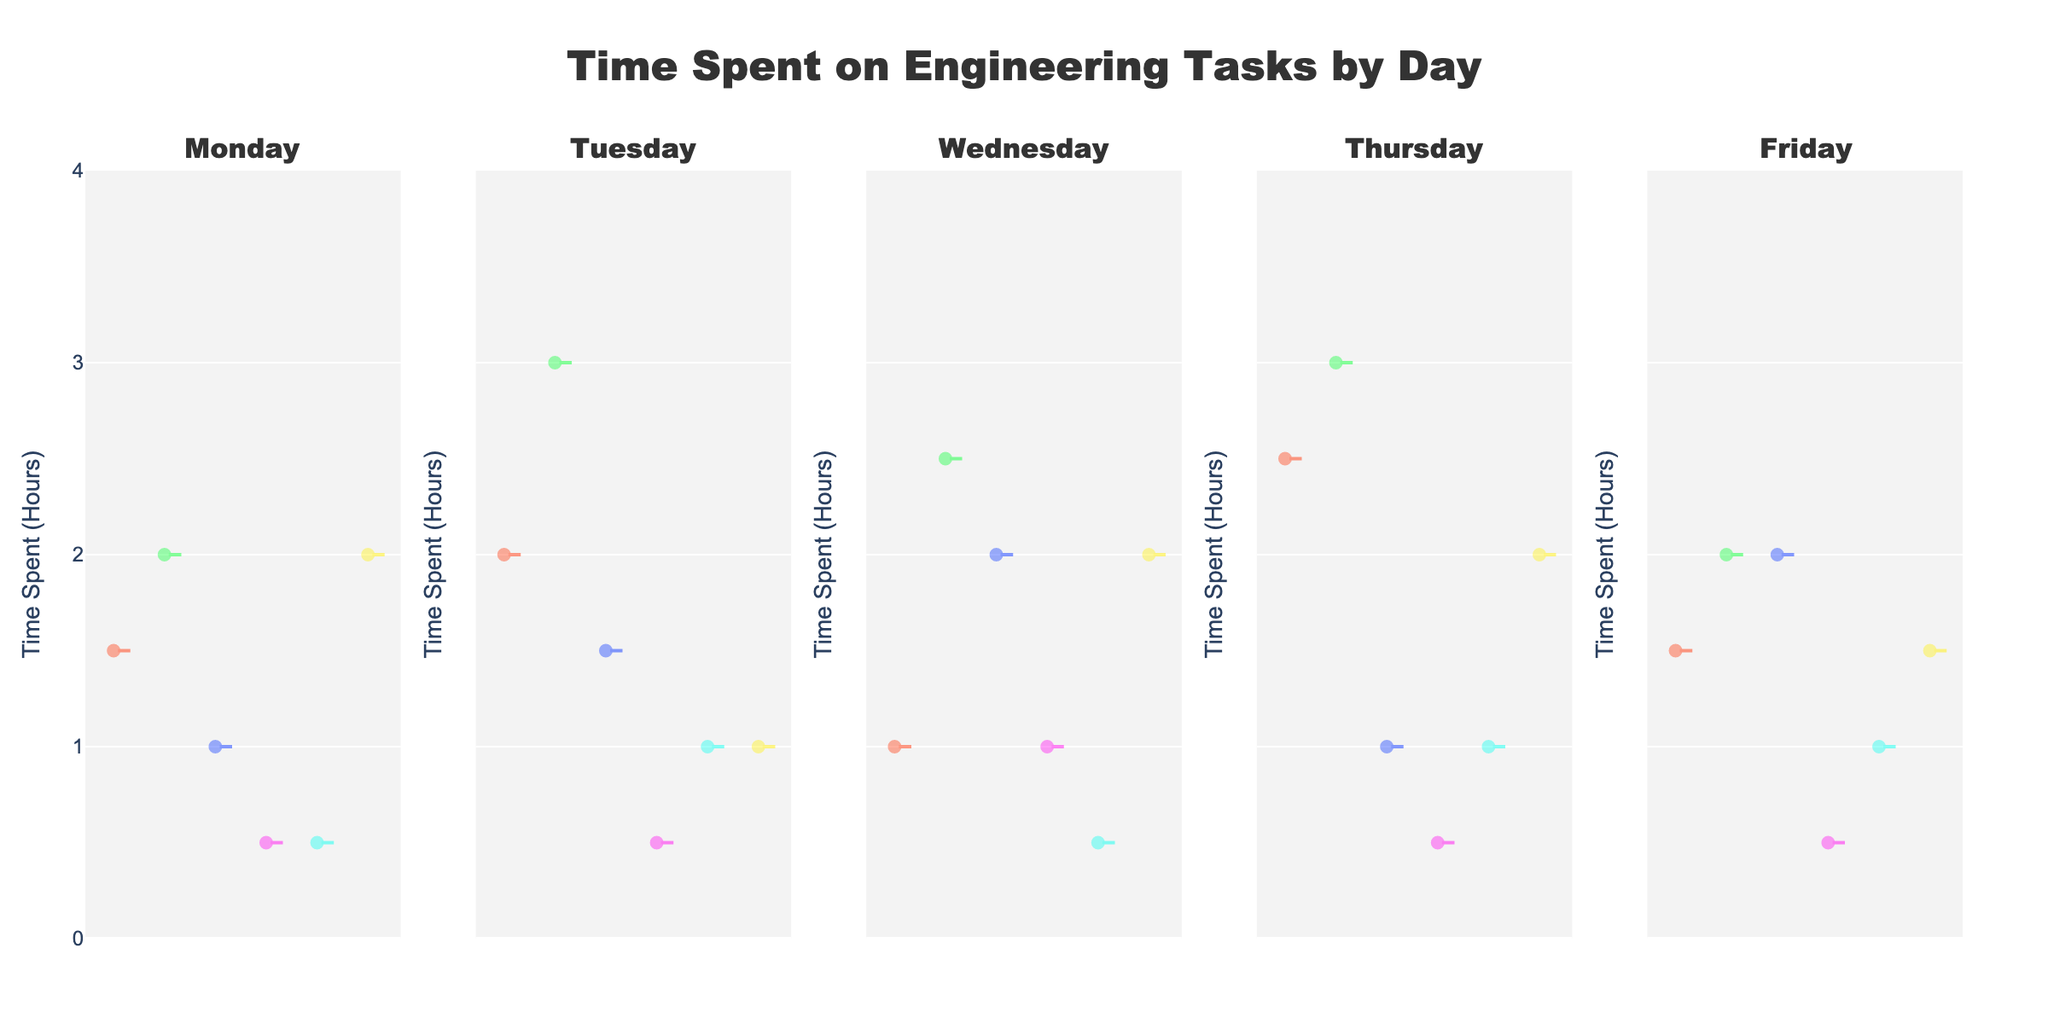What's the title of the figure? The title is usually found at the top of the figure and it provides a brief description of what the figure is about. In this case, the title is "Time Spent on Engineering Tasks by Day".
Answer: Time Spent on Engineering Tasks by Day What's the y-axis label on the figure? The y-axis label is typically along the vertical axis and specifies what is being measured. In this figure, the y-axis label is "Time Spent (Hours)".
Answer: Time Spent (Hours) Which two tasks have the highest median time spent on Tuesday? To determine the median time spent on Tuesday, locate the violin plots under the Tuesday subplot and observe which tasks have the highest medians (the widest parts at the center). Circuit Design and Coding have the highest medians on Tuesday.
Answer: Circuit Design, Coding Which day has the widest spread in time spent on Coding? Observe the violin plots for Coding on each day and note which day has the largest spread (the widest plot vertically). Thursday has the largest spread for Coding.
Answer: Thursday What is the smallest amount of time spent on Client Meeting on any day? Look at the violin plots for Client Meeting across all days. The smallest amount of time is seen on Tuesday and Friday, where the minimum value is 1 hour.
Answer: 1 hour Which day has the highest variation in Circuit Design time? The day with the highest variation in Circuit Design time can be observed by checking the spread of the violin plot on each day. Thursday has the highest variation.
Answer: Thursday How many data points are there for Simulation on Monday? Each point in the "Simulation" violin plot on Monday represents a data point. By observing the points displayed within the plot, there is 1 data point for Simulation on Monday.
Answer: 1 Compare the median time spent on Documentation between Wednesday and Friday. Which day has a higher median? To compare the median times, observe the central parts of the violin plots for Documentation on Wednesday and Friday. Wednesday has a higher median time.
Answer: Wednesday Is there any day where the time spent on Review is consistently lower than all other tasks? Review the violin plots for the task "Review" across all days and compare with other tasks. Review is consistently the lowest across all days.
Answer: Yes, consistently lower 